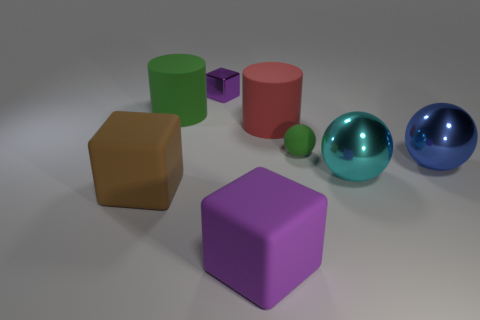The large purple rubber object is what shape?
Keep it short and to the point. Cube. There is a large brown object that is the same shape as the large purple object; what is its material?
Offer a terse response. Rubber. What number of metal objects have the same size as the green cylinder?
Ensure brevity in your answer.  2. There is a purple thing that is behind the cyan sphere; is there a large purple cube in front of it?
Ensure brevity in your answer.  Yes. How many purple objects are large shiny things or small metal things?
Make the answer very short. 1. The tiny metallic object has what color?
Your answer should be compact. Purple. The red object that is made of the same material as the green ball is what size?
Your answer should be very brief. Large. What number of other large rubber things have the same shape as the purple matte thing?
Provide a succinct answer. 1. Is there anything else that has the same size as the rubber ball?
Your response must be concise. Yes. What is the size of the block that is behind the large block on the left side of the big purple object?
Your response must be concise. Small. 